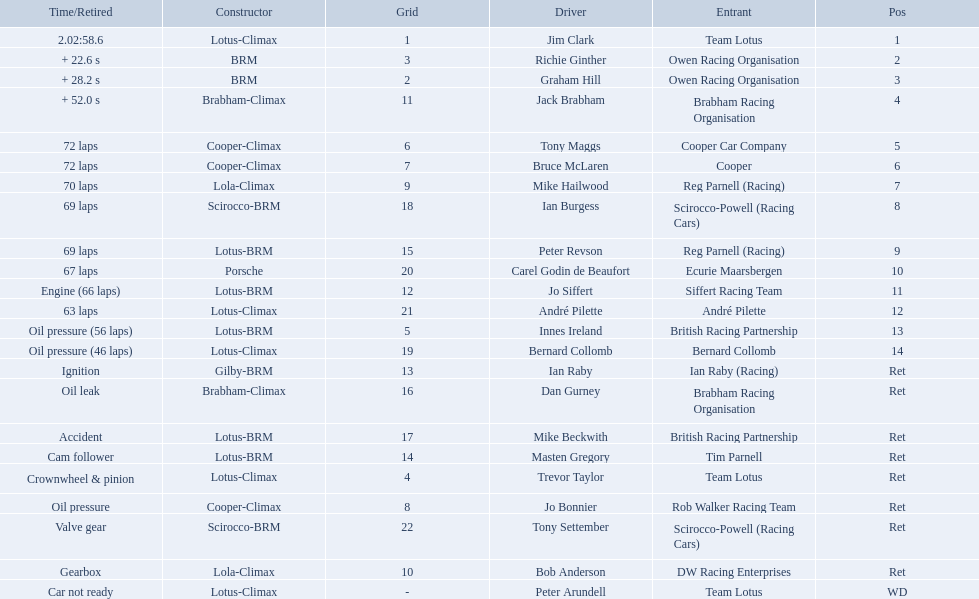Who were the drivers in the the 1963 international gold cup? Jim Clark, Richie Ginther, Graham Hill, Jack Brabham, Tony Maggs, Bruce McLaren, Mike Hailwood, Ian Burgess, Peter Revson, Carel Godin de Beaufort, Jo Siffert, André Pilette, Innes Ireland, Bernard Collomb, Ian Raby, Dan Gurney, Mike Beckwith, Masten Gregory, Trevor Taylor, Jo Bonnier, Tony Settember, Bob Anderson, Peter Arundell. Which drivers drove a cooper-climax car? Tony Maggs, Bruce McLaren, Jo Bonnier. What did these drivers place? 5, 6, Ret. What was the best placing position? 5. Who was the driver with this placing? Tony Maggs. 